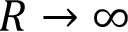<formula> <loc_0><loc_0><loc_500><loc_500>R \to \infty</formula> 